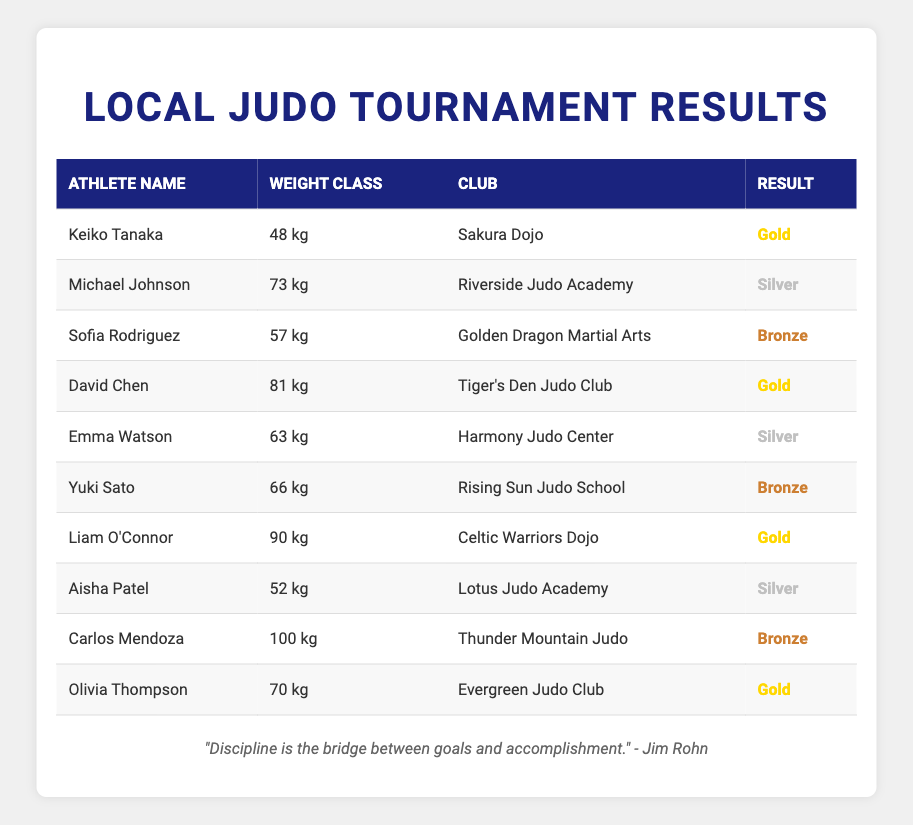What is the name of the athlete who won a Gold medal in the 48 kg category? The table shows that Keiko Tanaka competed in the 48 kg category and won a Gold medal.
Answer: Keiko Tanaka How many athletes won Silver medals? There are three athletes listed with Silver medals: Michael Johnson, Emma Watson, and Aisha Patel.
Answer: Three Which club had the most Gold medal winners? The Gold medals were won by athletes from three clubs: Sakura Dojo, Tiger's Den Judo Club, Celtic Warriors Dojo, and Evergreen Judo Club. Therefore, no club has more than one Gold medal winner.
Answer: None Is there an athlete from the Rising Sun Judo School who won a medal? Yuki Sato from Rising Sun Judo School is listed with a Bronze medal, confirming that an athlete from that club won a medal.
Answer: Yes What is the total number of medals awarded to athletes from the Tiger's Den Judo Club? David Chen won a Gold medal and is the only athlete from Tiger's Den Judo Club listed in the table, so the total number of medals is one.
Answer: One Which weight class had the highest number of Gold medal winners? Each weight class had one Gold medal winner, and no weight class has more than one Gold. Therefore, they all are equal in this regard.
Answer: None Who is the athlete with the highest weight class that won a medal? Carlos Mendoza competed in the 100 kg weight class and won a Bronze medal, making him the athlete with the highest weight class who won a medal in this tournament.
Answer: Carlos Mendoza What percentage of the total medals awarded were Gold? There were 4 Gold medals, 3 Silver medals, and 3 Bronze medals, making a total of 10 medals. The percentage of Gold medals is (4/10) * 100 = 40%.
Answer: 40% In which weight class did Olivia Thompson compete? The table specifically lists Olivia Thompson in the 70 kg weight class.
Answer: 70 kg 